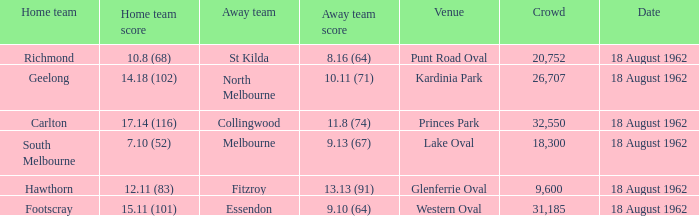What was the away team when the home team scored 10.8 (68)? St Kilda. 